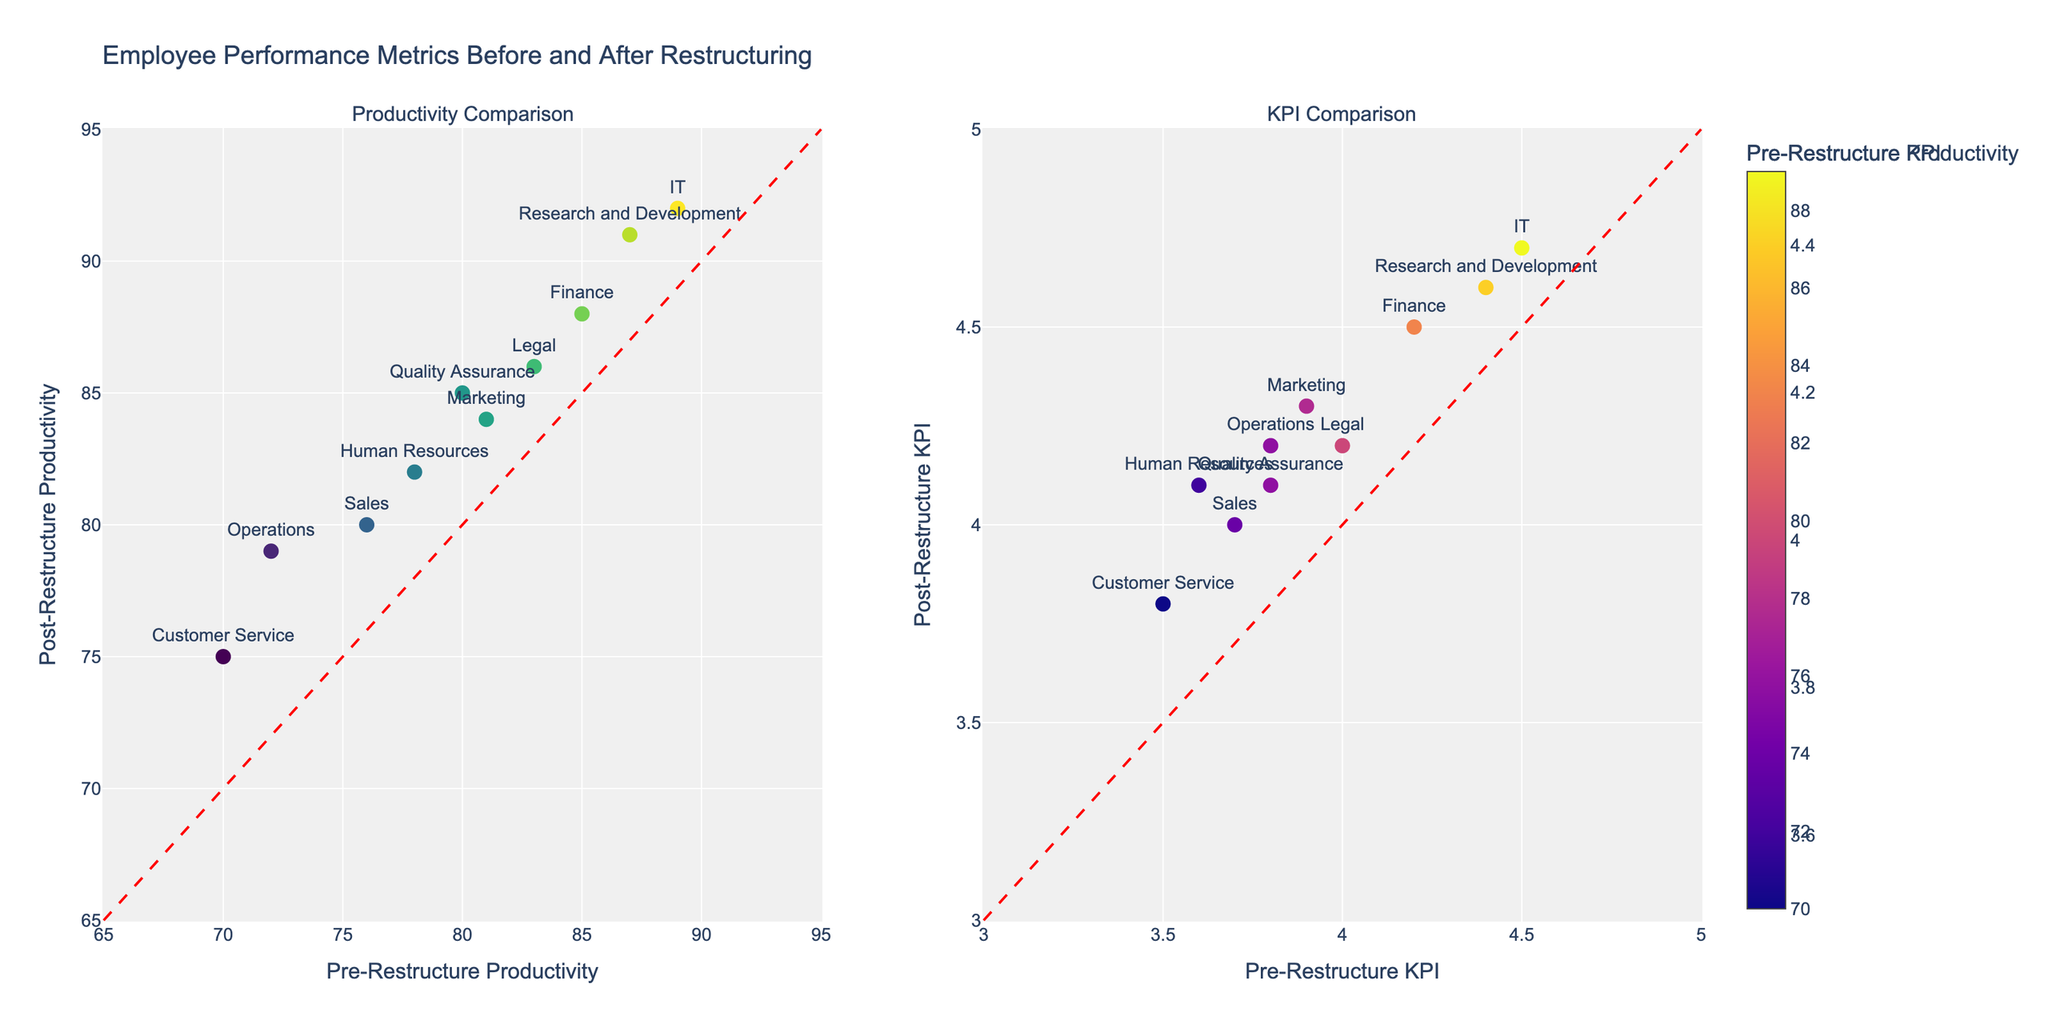How many data points are there in each subplot? Both subplots contain one data point for each department, which totals to 10 data points in each subplot.
Answer: 10 What is the title of the figure? The title of the figure is displayed at the top and reads "Employee Performance Metrics Before and After Restructuring."
Answer: Employee Performance Metrics Before and After Restructuring Which department shows the highest pre-restructure productivity? In the subplot for productivity comparison, the data point representing IT is the highest on the x-axis for pre-restructure productivity.
Answer: IT Which department has the lowest post-restructure KPI? In the KPI comparison subplot, the data point for Customer Service is the lowest on the y-axis for post-restructure KPI.
Answer: Customer Service Which department improved the most in productivity after restructuring? To find the department with the most improvement in productivity, we need to calculate the difference in productivity for each department. IT shows the largest increase (92 - 89 = 3).
Answer: IT Are there any departments that did not improve their productivity after restructuring? Checking the y-values for post-restructure productivity against the x-values for pre-restructure productivity, we see all data points lie above the y=x line, meaning all departments improved.
Answer: No Which department has the smallest improvement in KPI? Calculate the difference in KPI values for all departments; the smallest increase is for Legal (4.2 - 4.0 = 0.2).
Answer: Legal What is the average pre-restructure KPI for all departments? Sum the pre-restructure KPIs: 3.6 + 4.2 + 3.8 + 4.5 + 3.9 + 3.7 + 3.5 + 4.4 + 4.0 + 3.8 = 39.4. There are 10 departments, so the average is 39.4 / 10 = 3.94.
Answer: 3.94 Is the post-restructure productivity generally higher or lower than the pre-restructure productivity? All data points in the productivity comparison subplot are above the red y=x line, indicating generally higher post-restructure productivity.
Answer: Higher 